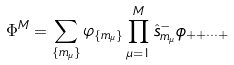<formula> <loc_0><loc_0><loc_500><loc_500>\Phi ^ { M } = \sum _ { \{ m _ { \mu } \} } \varphi _ { \{ m _ { \mu } \} } \prod _ { \mu = 1 } ^ { M } \hat { s } _ { m _ { \mu } } ^ { - } \phi _ { + + \cdots + }</formula> 